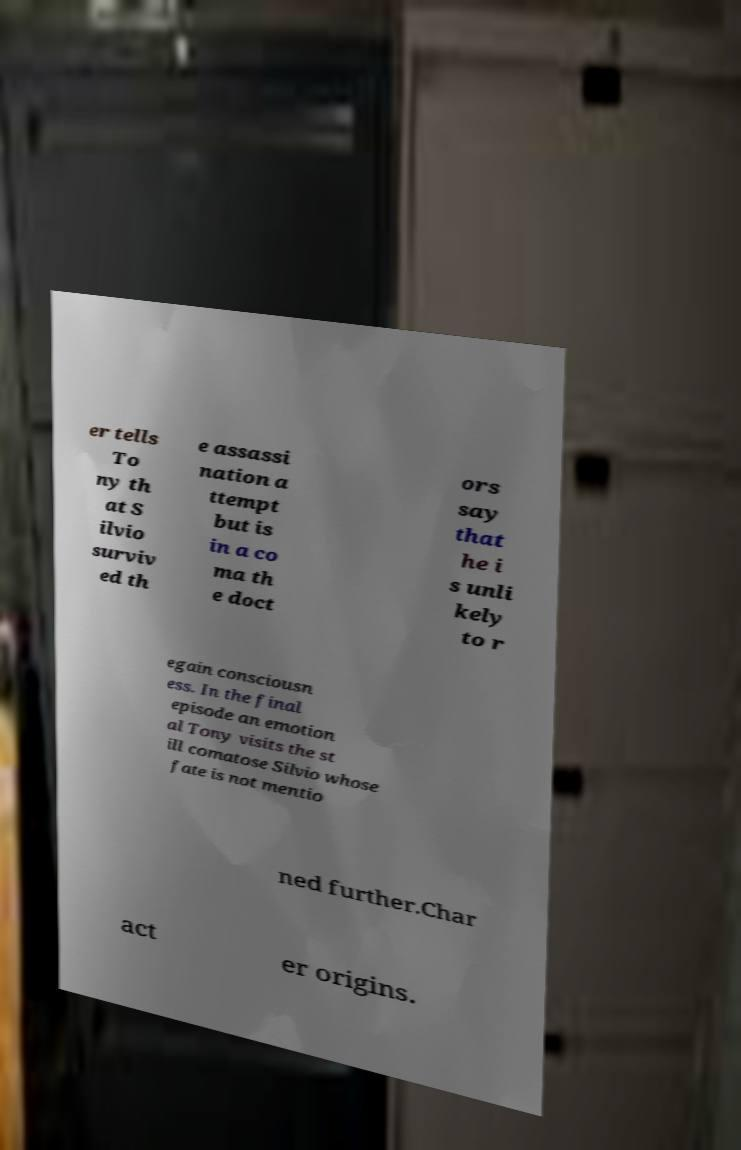What messages or text are displayed in this image? I need them in a readable, typed format. er tells To ny th at S ilvio surviv ed th e assassi nation a ttempt but is in a co ma th e doct ors say that he i s unli kely to r egain consciousn ess. In the final episode an emotion al Tony visits the st ill comatose Silvio whose fate is not mentio ned further.Char act er origins. 